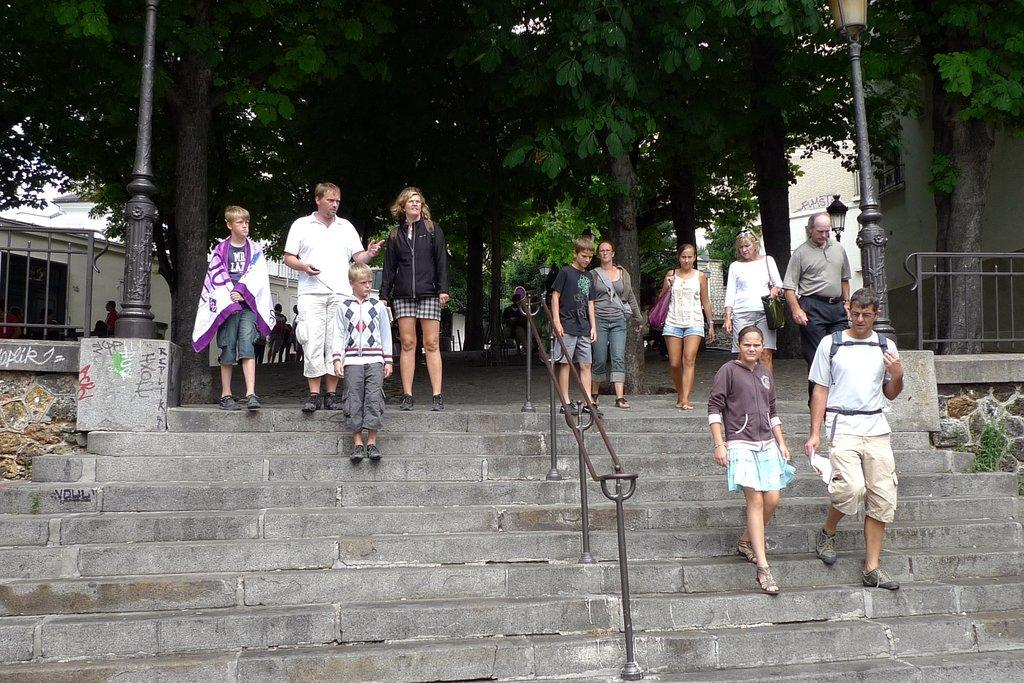What are the people in the image doing? There are people getting down the stairs in the image. Can you describe the man in the image? The man is wearing a backpack in the image. What are the women in the image carrying? There are women wearing bags in the image. What can be seen in the background of the image? There are trees, pole lights, and buildings visible in the image. What type of prose is being recited by the people in the image? There is no indication in the image that people are reciting prose or any form of literature. Can you tell me how many pans are visible in the image? There are no pans present in the image. 